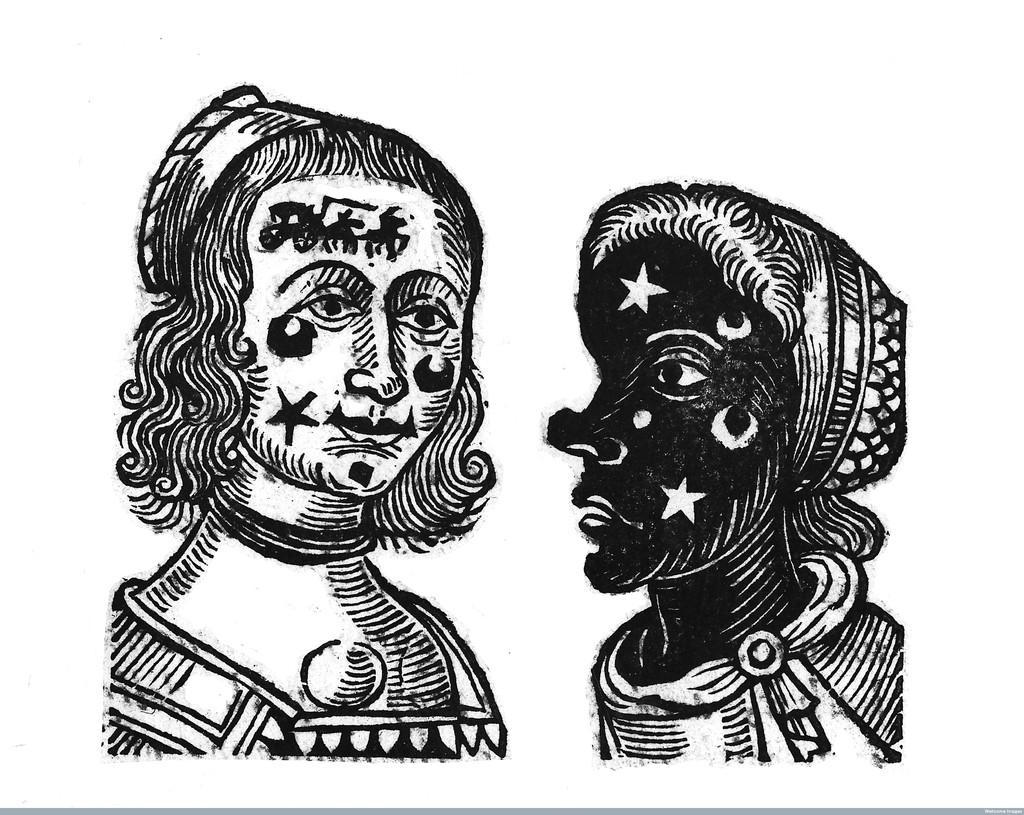What is the main subject of the image? The main subject of the image is depictions of women. Can you describe the location or setting of the image? The provided facts do not mention any specific location or setting for the image. What type of school can be seen in the image? There is no school present in the image; it only features depictions of women. 